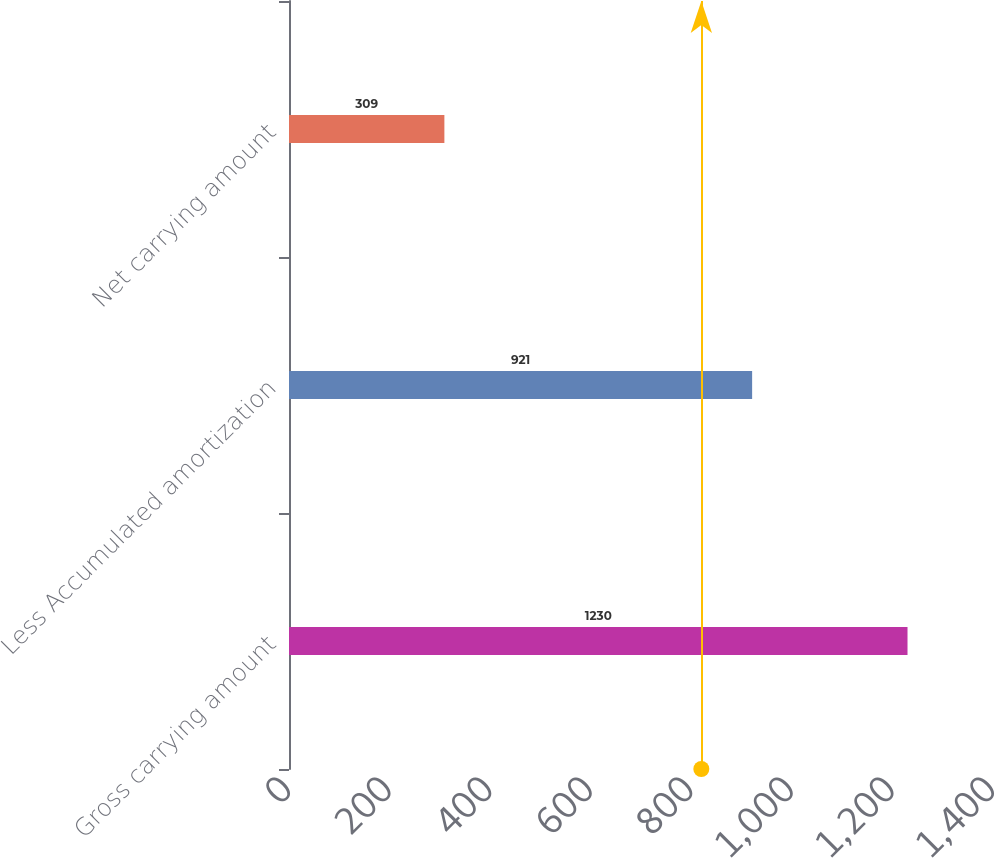Convert chart. <chart><loc_0><loc_0><loc_500><loc_500><bar_chart><fcel>Gross carrying amount<fcel>Less Accumulated amortization<fcel>Net carrying amount<nl><fcel>1230<fcel>921<fcel>309<nl></chart> 